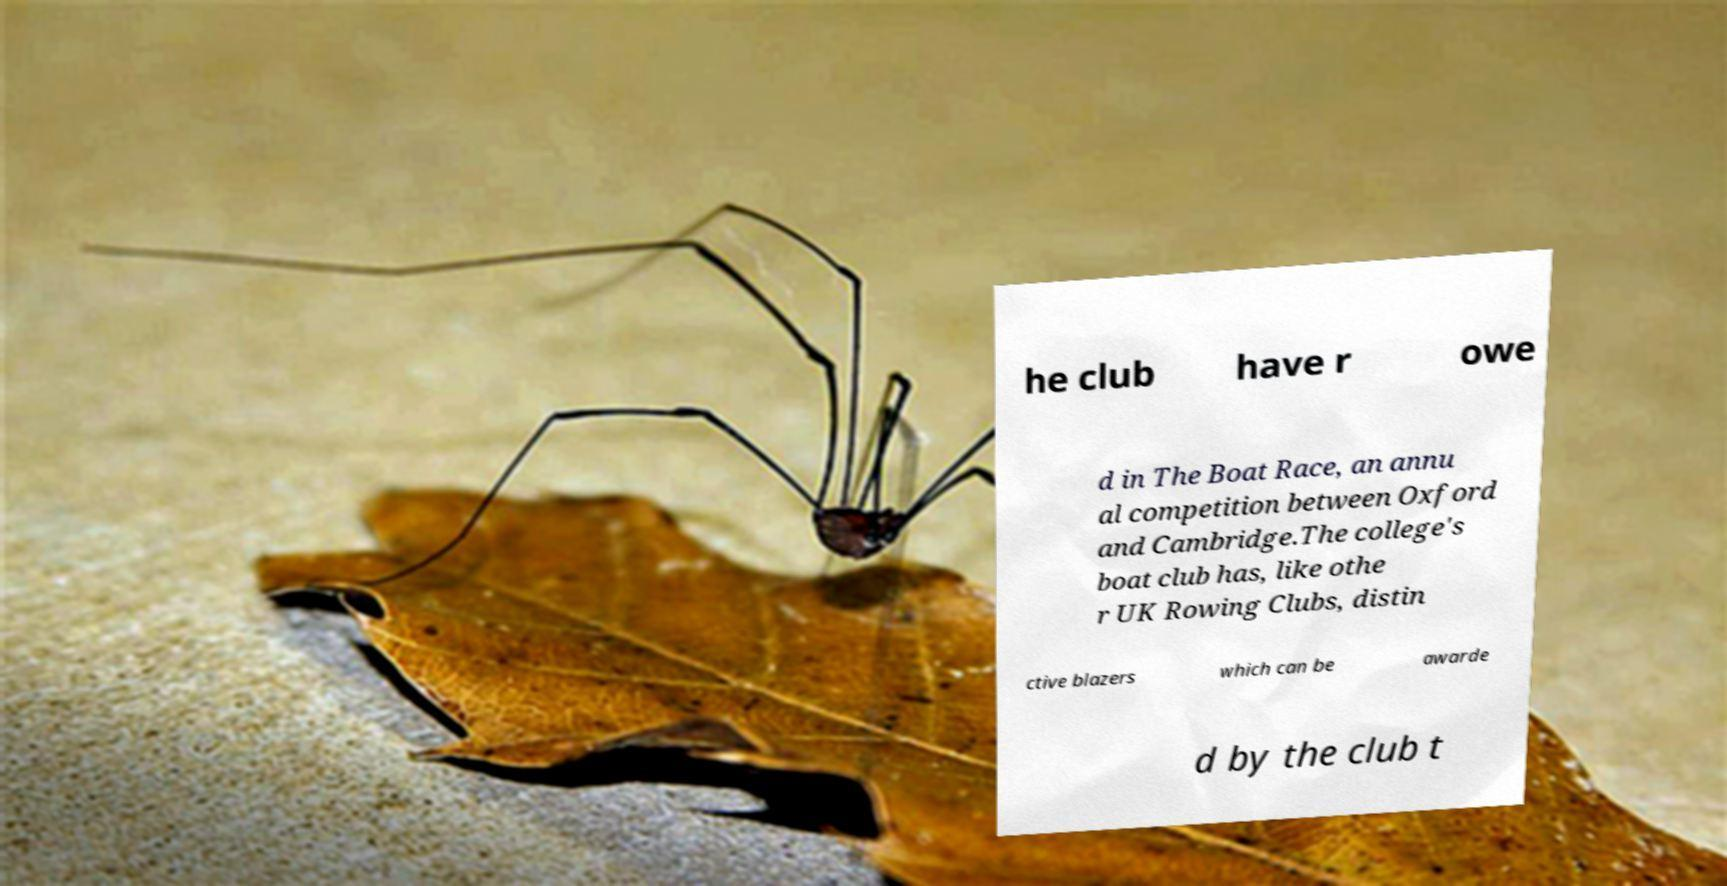Can you accurately transcribe the text from the provided image for me? he club have r owe d in The Boat Race, an annu al competition between Oxford and Cambridge.The college's boat club has, like othe r UK Rowing Clubs, distin ctive blazers which can be awarde d by the club t 